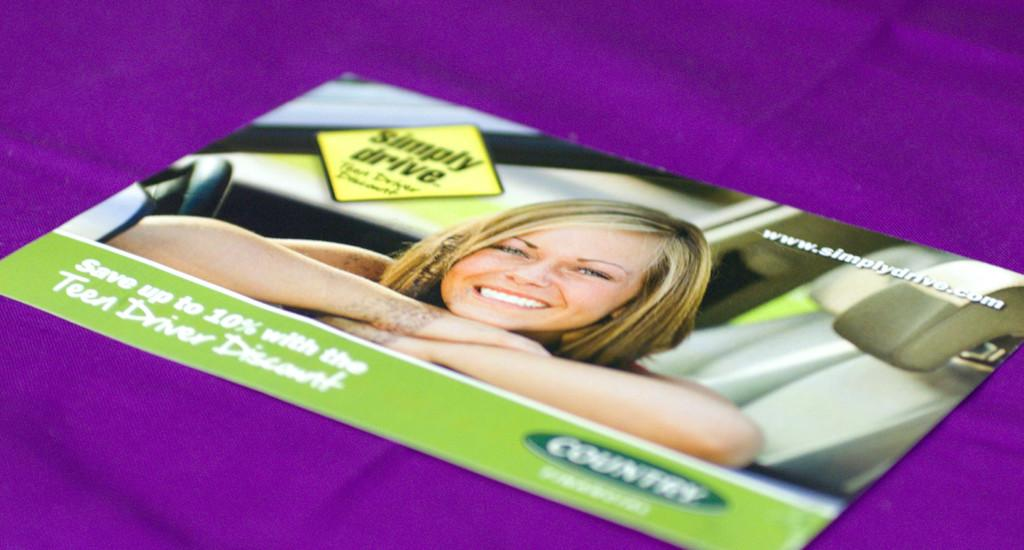What color is the cloth that is visible in the image? There is a purple cloth in the image. What is placed on top of the purple cloth? There is a pamphlet on the purple cloth. What can be seen on the pamphlet? The pamphlet has a picture of a woman. What else is present on the pamphlet besides the image? There is text written on the pamphlet. What type of ear is visible on the woman's picture on the pamphlet? There is no ear visible on the woman's picture on the pamphlet; it only shows her face. What feeling does the base of the purple cloth evoke in the image? There is no mention of a base for the purple cloth, nor any indication of feelings evoked by it in the image. 